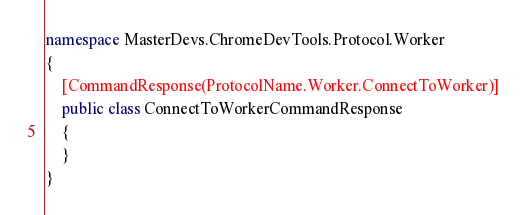Convert code to text. <code><loc_0><loc_0><loc_500><loc_500><_C#_>namespace MasterDevs.ChromeDevTools.Protocol.Worker
{
	[CommandResponse(ProtocolName.Worker.ConnectToWorker)]
	public class ConnectToWorkerCommandResponse
	{
	}
}
</code> 